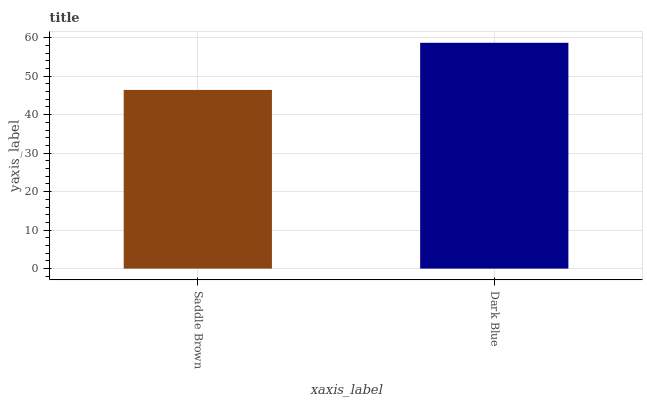Is Saddle Brown the minimum?
Answer yes or no. Yes. Is Dark Blue the maximum?
Answer yes or no. Yes. Is Dark Blue the minimum?
Answer yes or no. No. Is Dark Blue greater than Saddle Brown?
Answer yes or no. Yes. Is Saddle Brown less than Dark Blue?
Answer yes or no. Yes. Is Saddle Brown greater than Dark Blue?
Answer yes or no. No. Is Dark Blue less than Saddle Brown?
Answer yes or no. No. Is Dark Blue the high median?
Answer yes or no. Yes. Is Saddle Brown the low median?
Answer yes or no. Yes. Is Saddle Brown the high median?
Answer yes or no. No. Is Dark Blue the low median?
Answer yes or no. No. 